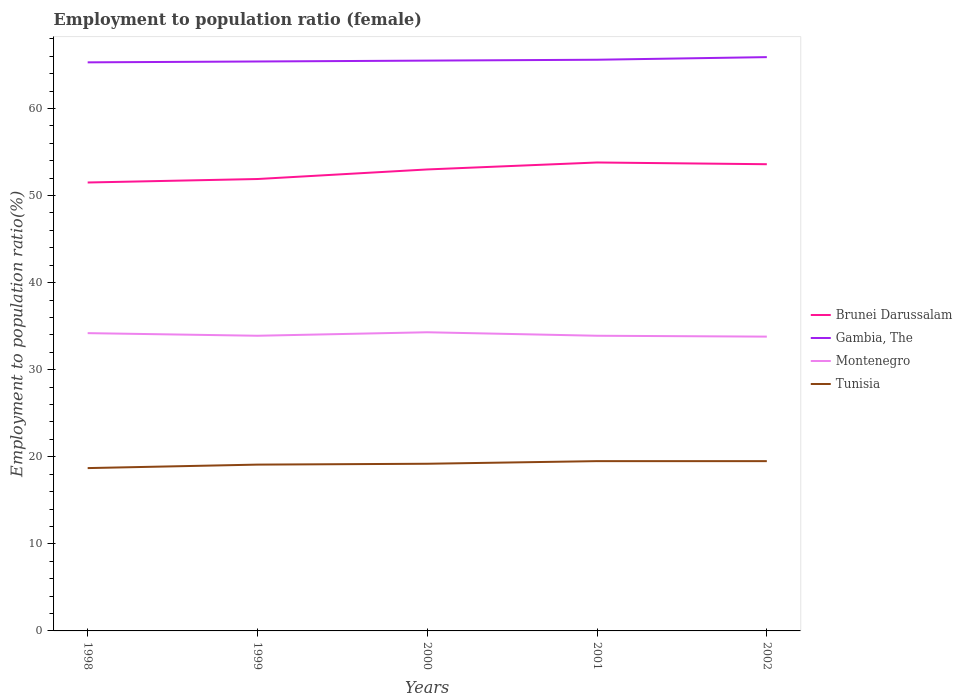Does the line corresponding to Tunisia intersect with the line corresponding to Brunei Darussalam?
Ensure brevity in your answer.  No. Is the number of lines equal to the number of legend labels?
Your response must be concise. Yes. Across all years, what is the maximum employment to population ratio in Brunei Darussalam?
Give a very brief answer. 51.5. In which year was the employment to population ratio in Brunei Darussalam maximum?
Make the answer very short. 1998. What is the total employment to population ratio in Gambia, The in the graph?
Provide a succinct answer. -0.1. What is the difference between the highest and the lowest employment to population ratio in Montenegro?
Ensure brevity in your answer.  2. Is the employment to population ratio in Tunisia strictly greater than the employment to population ratio in Brunei Darussalam over the years?
Your answer should be very brief. Yes. How many lines are there?
Offer a very short reply. 4. How many years are there in the graph?
Make the answer very short. 5. What is the difference between two consecutive major ticks on the Y-axis?
Your answer should be very brief. 10. Does the graph contain any zero values?
Your answer should be compact. No. Does the graph contain grids?
Your response must be concise. No. What is the title of the graph?
Your response must be concise. Employment to population ratio (female). Does "St. Kitts and Nevis" appear as one of the legend labels in the graph?
Your response must be concise. No. What is the label or title of the X-axis?
Provide a succinct answer. Years. What is the Employment to population ratio(%) of Brunei Darussalam in 1998?
Offer a very short reply. 51.5. What is the Employment to population ratio(%) of Gambia, The in 1998?
Your response must be concise. 65.3. What is the Employment to population ratio(%) in Montenegro in 1998?
Your response must be concise. 34.2. What is the Employment to population ratio(%) of Tunisia in 1998?
Your answer should be very brief. 18.7. What is the Employment to population ratio(%) in Brunei Darussalam in 1999?
Offer a very short reply. 51.9. What is the Employment to population ratio(%) of Gambia, The in 1999?
Your answer should be very brief. 65.4. What is the Employment to population ratio(%) of Montenegro in 1999?
Your response must be concise. 33.9. What is the Employment to population ratio(%) of Tunisia in 1999?
Make the answer very short. 19.1. What is the Employment to population ratio(%) of Brunei Darussalam in 2000?
Your answer should be compact. 53. What is the Employment to population ratio(%) of Gambia, The in 2000?
Your answer should be compact. 65.5. What is the Employment to population ratio(%) in Montenegro in 2000?
Give a very brief answer. 34.3. What is the Employment to population ratio(%) of Tunisia in 2000?
Give a very brief answer. 19.2. What is the Employment to population ratio(%) of Brunei Darussalam in 2001?
Provide a succinct answer. 53.8. What is the Employment to population ratio(%) in Gambia, The in 2001?
Ensure brevity in your answer.  65.6. What is the Employment to population ratio(%) in Montenegro in 2001?
Make the answer very short. 33.9. What is the Employment to population ratio(%) in Tunisia in 2001?
Make the answer very short. 19.5. What is the Employment to population ratio(%) of Brunei Darussalam in 2002?
Offer a very short reply. 53.6. What is the Employment to population ratio(%) in Gambia, The in 2002?
Make the answer very short. 65.9. What is the Employment to population ratio(%) in Montenegro in 2002?
Your answer should be very brief. 33.8. What is the Employment to population ratio(%) of Tunisia in 2002?
Give a very brief answer. 19.5. Across all years, what is the maximum Employment to population ratio(%) of Brunei Darussalam?
Your answer should be very brief. 53.8. Across all years, what is the maximum Employment to population ratio(%) in Gambia, The?
Ensure brevity in your answer.  65.9. Across all years, what is the maximum Employment to population ratio(%) of Montenegro?
Provide a short and direct response. 34.3. Across all years, what is the minimum Employment to population ratio(%) in Brunei Darussalam?
Make the answer very short. 51.5. Across all years, what is the minimum Employment to population ratio(%) in Gambia, The?
Give a very brief answer. 65.3. Across all years, what is the minimum Employment to population ratio(%) in Montenegro?
Your response must be concise. 33.8. Across all years, what is the minimum Employment to population ratio(%) of Tunisia?
Ensure brevity in your answer.  18.7. What is the total Employment to population ratio(%) of Brunei Darussalam in the graph?
Your response must be concise. 263.8. What is the total Employment to population ratio(%) of Gambia, The in the graph?
Offer a very short reply. 327.7. What is the total Employment to population ratio(%) of Montenegro in the graph?
Give a very brief answer. 170.1. What is the total Employment to population ratio(%) of Tunisia in the graph?
Offer a terse response. 96. What is the difference between the Employment to population ratio(%) in Brunei Darussalam in 1998 and that in 1999?
Provide a short and direct response. -0.4. What is the difference between the Employment to population ratio(%) of Brunei Darussalam in 1998 and that in 2000?
Your answer should be compact. -1.5. What is the difference between the Employment to population ratio(%) of Gambia, The in 1998 and that in 2000?
Offer a terse response. -0.2. What is the difference between the Employment to population ratio(%) of Montenegro in 1998 and that in 2000?
Provide a short and direct response. -0.1. What is the difference between the Employment to population ratio(%) of Tunisia in 1998 and that in 2000?
Ensure brevity in your answer.  -0.5. What is the difference between the Employment to population ratio(%) of Gambia, The in 1998 and that in 2001?
Offer a terse response. -0.3. What is the difference between the Employment to population ratio(%) in Tunisia in 1998 and that in 2001?
Make the answer very short. -0.8. What is the difference between the Employment to population ratio(%) in Brunei Darussalam in 1998 and that in 2002?
Make the answer very short. -2.1. What is the difference between the Employment to population ratio(%) in Gambia, The in 1998 and that in 2002?
Your answer should be very brief. -0.6. What is the difference between the Employment to population ratio(%) of Montenegro in 1998 and that in 2002?
Provide a short and direct response. 0.4. What is the difference between the Employment to population ratio(%) of Tunisia in 1998 and that in 2002?
Your response must be concise. -0.8. What is the difference between the Employment to population ratio(%) in Brunei Darussalam in 1999 and that in 2000?
Make the answer very short. -1.1. What is the difference between the Employment to population ratio(%) in Brunei Darussalam in 1999 and that in 2001?
Provide a short and direct response. -1.9. What is the difference between the Employment to population ratio(%) in Montenegro in 1999 and that in 2001?
Your response must be concise. 0. What is the difference between the Employment to population ratio(%) in Brunei Darussalam in 2000 and that in 2001?
Provide a short and direct response. -0.8. What is the difference between the Employment to population ratio(%) in Montenegro in 2000 and that in 2001?
Provide a short and direct response. 0.4. What is the difference between the Employment to population ratio(%) of Montenegro in 2000 and that in 2002?
Offer a terse response. 0.5. What is the difference between the Employment to population ratio(%) in Brunei Darussalam in 2001 and that in 2002?
Offer a very short reply. 0.2. What is the difference between the Employment to population ratio(%) in Gambia, The in 2001 and that in 2002?
Offer a terse response. -0.3. What is the difference between the Employment to population ratio(%) in Montenegro in 2001 and that in 2002?
Keep it short and to the point. 0.1. What is the difference between the Employment to population ratio(%) in Tunisia in 2001 and that in 2002?
Provide a short and direct response. 0. What is the difference between the Employment to population ratio(%) in Brunei Darussalam in 1998 and the Employment to population ratio(%) in Gambia, The in 1999?
Ensure brevity in your answer.  -13.9. What is the difference between the Employment to population ratio(%) of Brunei Darussalam in 1998 and the Employment to population ratio(%) of Montenegro in 1999?
Give a very brief answer. 17.6. What is the difference between the Employment to population ratio(%) in Brunei Darussalam in 1998 and the Employment to population ratio(%) in Tunisia in 1999?
Offer a terse response. 32.4. What is the difference between the Employment to population ratio(%) of Gambia, The in 1998 and the Employment to population ratio(%) of Montenegro in 1999?
Provide a short and direct response. 31.4. What is the difference between the Employment to population ratio(%) in Gambia, The in 1998 and the Employment to population ratio(%) in Tunisia in 1999?
Give a very brief answer. 46.2. What is the difference between the Employment to population ratio(%) in Montenegro in 1998 and the Employment to population ratio(%) in Tunisia in 1999?
Give a very brief answer. 15.1. What is the difference between the Employment to population ratio(%) in Brunei Darussalam in 1998 and the Employment to population ratio(%) in Gambia, The in 2000?
Your response must be concise. -14. What is the difference between the Employment to population ratio(%) of Brunei Darussalam in 1998 and the Employment to population ratio(%) of Montenegro in 2000?
Offer a terse response. 17.2. What is the difference between the Employment to population ratio(%) of Brunei Darussalam in 1998 and the Employment to population ratio(%) of Tunisia in 2000?
Your response must be concise. 32.3. What is the difference between the Employment to population ratio(%) of Gambia, The in 1998 and the Employment to population ratio(%) of Tunisia in 2000?
Keep it short and to the point. 46.1. What is the difference between the Employment to population ratio(%) of Montenegro in 1998 and the Employment to population ratio(%) of Tunisia in 2000?
Provide a succinct answer. 15. What is the difference between the Employment to population ratio(%) in Brunei Darussalam in 1998 and the Employment to population ratio(%) in Gambia, The in 2001?
Make the answer very short. -14.1. What is the difference between the Employment to population ratio(%) in Brunei Darussalam in 1998 and the Employment to population ratio(%) in Montenegro in 2001?
Your response must be concise. 17.6. What is the difference between the Employment to population ratio(%) of Gambia, The in 1998 and the Employment to population ratio(%) of Montenegro in 2001?
Your response must be concise. 31.4. What is the difference between the Employment to population ratio(%) in Gambia, The in 1998 and the Employment to population ratio(%) in Tunisia in 2001?
Provide a succinct answer. 45.8. What is the difference between the Employment to population ratio(%) in Montenegro in 1998 and the Employment to population ratio(%) in Tunisia in 2001?
Give a very brief answer. 14.7. What is the difference between the Employment to population ratio(%) in Brunei Darussalam in 1998 and the Employment to population ratio(%) in Gambia, The in 2002?
Provide a short and direct response. -14.4. What is the difference between the Employment to population ratio(%) in Brunei Darussalam in 1998 and the Employment to population ratio(%) in Montenegro in 2002?
Make the answer very short. 17.7. What is the difference between the Employment to population ratio(%) in Gambia, The in 1998 and the Employment to population ratio(%) in Montenegro in 2002?
Ensure brevity in your answer.  31.5. What is the difference between the Employment to population ratio(%) of Gambia, The in 1998 and the Employment to population ratio(%) of Tunisia in 2002?
Your answer should be very brief. 45.8. What is the difference between the Employment to population ratio(%) of Brunei Darussalam in 1999 and the Employment to population ratio(%) of Tunisia in 2000?
Your response must be concise. 32.7. What is the difference between the Employment to population ratio(%) in Gambia, The in 1999 and the Employment to population ratio(%) in Montenegro in 2000?
Provide a succinct answer. 31.1. What is the difference between the Employment to population ratio(%) in Gambia, The in 1999 and the Employment to population ratio(%) in Tunisia in 2000?
Make the answer very short. 46.2. What is the difference between the Employment to population ratio(%) in Brunei Darussalam in 1999 and the Employment to population ratio(%) in Gambia, The in 2001?
Ensure brevity in your answer.  -13.7. What is the difference between the Employment to population ratio(%) in Brunei Darussalam in 1999 and the Employment to population ratio(%) in Tunisia in 2001?
Your answer should be compact. 32.4. What is the difference between the Employment to population ratio(%) of Gambia, The in 1999 and the Employment to population ratio(%) of Montenegro in 2001?
Keep it short and to the point. 31.5. What is the difference between the Employment to population ratio(%) in Gambia, The in 1999 and the Employment to population ratio(%) in Tunisia in 2001?
Your answer should be very brief. 45.9. What is the difference between the Employment to population ratio(%) of Montenegro in 1999 and the Employment to population ratio(%) of Tunisia in 2001?
Ensure brevity in your answer.  14.4. What is the difference between the Employment to population ratio(%) in Brunei Darussalam in 1999 and the Employment to population ratio(%) in Montenegro in 2002?
Ensure brevity in your answer.  18.1. What is the difference between the Employment to population ratio(%) in Brunei Darussalam in 1999 and the Employment to population ratio(%) in Tunisia in 2002?
Offer a very short reply. 32.4. What is the difference between the Employment to population ratio(%) of Gambia, The in 1999 and the Employment to population ratio(%) of Montenegro in 2002?
Your answer should be compact. 31.6. What is the difference between the Employment to population ratio(%) of Gambia, The in 1999 and the Employment to population ratio(%) of Tunisia in 2002?
Provide a short and direct response. 45.9. What is the difference between the Employment to population ratio(%) of Montenegro in 1999 and the Employment to population ratio(%) of Tunisia in 2002?
Keep it short and to the point. 14.4. What is the difference between the Employment to population ratio(%) of Brunei Darussalam in 2000 and the Employment to population ratio(%) of Gambia, The in 2001?
Keep it short and to the point. -12.6. What is the difference between the Employment to population ratio(%) of Brunei Darussalam in 2000 and the Employment to population ratio(%) of Montenegro in 2001?
Give a very brief answer. 19.1. What is the difference between the Employment to population ratio(%) of Brunei Darussalam in 2000 and the Employment to population ratio(%) of Tunisia in 2001?
Your answer should be compact. 33.5. What is the difference between the Employment to population ratio(%) of Gambia, The in 2000 and the Employment to population ratio(%) of Montenegro in 2001?
Your response must be concise. 31.6. What is the difference between the Employment to population ratio(%) of Brunei Darussalam in 2000 and the Employment to population ratio(%) of Montenegro in 2002?
Your answer should be compact. 19.2. What is the difference between the Employment to population ratio(%) in Brunei Darussalam in 2000 and the Employment to population ratio(%) in Tunisia in 2002?
Give a very brief answer. 33.5. What is the difference between the Employment to population ratio(%) in Gambia, The in 2000 and the Employment to population ratio(%) in Montenegro in 2002?
Keep it short and to the point. 31.7. What is the difference between the Employment to population ratio(%) of Gambia, The in 2000 and the Employment to population ratio(%) of Tunisia in 2002?
Provide a succinct answer. 46. What is the difference between the Employment to population ratio(%) of Montenegro in 2000 and the Employment to population ratio(%) of Tunisia in 2002?
Your response must be concise. 14.8. What is the difference between the Employment to population ratio(%) in Brunei Darussalam in 2001 and the Employment to population ratio(%) in Tunisia in 2002?
Keep it short and to the point. 34.3. What is the difference between the Employment to population ratio(%) in Gambia, The in 2001 and the Employment to population ratio(%) in Montenegro in 2002?
Your answer should be compact. 31.8. What is the difference between the Employment to population ratio(%) of Gambia, The in 2001 and the Employment to population ratio(%) of Tunisia in 2002?
Provide a succinct answer. 46.1. What is the difference between the Employment to population ratio(%) in Montenegro in 2001 and the Employment to population ratio(%) in Tunisia in 2002?
Your response must be concise. 14.4. What is the average Employment to population ratio(%) of Brunei Darussalam per year?
Make the answer very short. 52.76. What is the average Employment to population ratio(%) in Gambia, The per year?
Offer a terse response. 65.54. What is the average Employment to population ratio(%) in Montenegro per year?
Ensure brevity in your answer.  34.02. In the year 1998, what is the difference between the Employment to population ratio(%) of Brunei Darussalam and Employment to population ratio(%) of Gambia, The?
Your response must be concise. -13.8. In the year 1998, what is the difference between the Employment to population ratio(%) of Brunei Darussalam and Employment to population ratio(%) of Tunisia?
Your answer should be very brief. 32.8. In the year 1998, what is the difference between the Employment to population ratio(%) in Gambia, The and Employment to population ratio(%) in Montenegro?
Your answer should be compact. 31.1. In the year 1998, what is the difference between the Employment to population ratio(%) of Gambia, The and Employment to population ratio(%) of Tunisia?
Offer a very short reply. 46.6. In the year 1999, what is the difference between the Employment to population ratio(%) in Brunei Darussalam and Employment to population ratio(%) in Tunisia?
Provide a short and direct response. 32.8. In the year 1999, what is the difference between the Employment to population ratio(%) in Gambia, The and Employment to population ratio(%) in Montenegro?
Ensure brevity in your answer.  31.5. In the year 1999, what is the difference between the Employment to population ratio(%) of Gambia, The and Employment to population ratio(%) of Tunisia?
Make the answer very short. 46.3. In the year 2000, what is the difference between the Employment to population ratio(%) of Brunei Darussalam and Employment to population ratio(%) of Tunisia?
Make the answer very short. 33.8. In the year 2000, what is the difference between the Employment to population ratio(%) in Gambia, The and Employment to population ratio(%) in Montenegro?
Provide a succinct answer. 31.2. In the year 2000, what is the difference between the Employment to population ratio(%) in Gambia, The and Employment to population ratio(%) in Tunisia?
Your response must be concise. 46.3. In the year 2000, what is the difference between the Employment to population ratio(%) of Montenegro and Employment to population ratio(%) of Tunisia?
Offer a terse response. 15.1. In the year 2001, what is the difference between the Employment to population ratio(%) in Brunei Darussalam and Employment to population ratio(%) in Montenegro?
Your answer should be compact. 19.9. In the year 2001, what is the difference between the Employment to population ratio(%) of Brunei Darussalam and Employment to population ratio(%) of Tunisia?
Make the answer very short. 34.3. In the year 2001, what is the difference between the Employment to population ratio(%) in Gambia, The and Employment to population ratio(%) in Montenegro?
Provide a short and direct response. 31.7. In the year 2001, what is the difference between the Employment to population ratio(%) in Gambia, The and Employment to population ratio(%) in Tunisia?
Offer a terse response. 46.1. In the year 2001, what is the difference between the Employment to population ratio(%) in Montenegro and Employment to population ratio(%) in Tunisia?
Your response must be concise. 14.4. In the year 2002, what is the difference between the Employment to population ratio(%) in Brunei Darussalam and Employment to population ratio(%) in Gambia, The?
Keep it short and to the point. -12.3. In the year 2002, what is the difference between the Employment to population ratio(%) in Brunei Darussalam and Employment to population ratio(%) in Montenegro?
Give a very brief answer. 19.8. In the year 2002, what is the difference between the Employment to population ratio(%) in Brunei Darussalam and Employment to population ratio(%) in Tunisia?
Your answer should be very brief. 34.1. In the year 2002, what is the difference between the Employment to population ratio(%) of Gambia, The and Employment to population ratio(%) of Montenegro?
Your response must be concise. 32.1. In the year 2002, what is the difference between the Employment to population ratio(%) of Gambia, The and Employment to population ratio(%) of Tunisia?
Give a very brief answer. 46.4. In the year 2002, what is the difference between the Employment to population ratio(%) in Montenegro and Employment to population ratio(%) in Tunisia?
Keep it short and to the point. 14.3. What is the ratio of the Employment to population ratio(%) of Brunei Darussalam in 1998 to that in 1999?
Provide a short and direct response. 0.99. What is the ratio of the Employment to population ratio(%) of Gambia, The in 1998 to that in 1999?
Give a very brief answer. 1. What is the ratio of the Employment to population ratio(%) in Montenegro in 1998 to that in 1999?
Your answer should be compact. 1.01. What is the ratio of the Employment to population ratio(%) in Tunisia in 1998 to that in 1999?
Provide a succinct answer. 0.98. What is the ratio of the Employment to population ratio(%) in Brunei Darussalam in 1998 to that in 2000?
Keep it short and to the point. 0.97. What is the ratio of the Employment to population ratio(%) of Gambia, The in 1998 to that in 2000?
Make the answer very short. 1. What is the ratio of the Employment to population ratio(%) in Montenegro in 1998 to that in 2000?
Your answer should be very brief. 1. What is the ratio of the Employment to population ratio(%) in Brunei Darussalam in 1998 to that in 2001?
Ensure brevity in your answer.  0.96. What is the ratio of the Employment to population ratio(%) in Montenegro in 1998 to that in 2001?
Make the answer very short. 1.01. What is the ratio of the Employment to population ratio(%) of Brunei Darussalam in 1998 to that in 2002?
Give a very brief answer. 0.96. What is the ratio of the Employment to population ratio(%) of Gambia, The in 1998 to that in 2002?
Your answer should be very brief. 0.99. What is the ratio of the Employment to population ratio(%) of Montenegro in 1998 to that in 2002?
Offer a very short reply. 1.01. What is the ratio of the Employment to population ratio(%) of Brunei Darussalam in 1999 to that in 2000?
Give a very brief answer. 0.98. What is the ratio of the Employment to population ratio(%) of Montenegro in 1999 to that in 2000?
Provide a succinct answer. 0.99. What is the ratio of the Employment to population ratio(%) in Brunei Darussalam in 1999 to that in 2001?
Ensure brevity in your answer.  0.96. What is the ratio of the Employment to population ratio(%) of Gambia, The in 1999 to that in 2001?
Your answer should be very brief. 1. What is the ratio of the Employment to population ratio(%) in Tunisia in 1999 to that in 2001?
Give a very brief answer. 0.98. What is the ratio of the Employment to population ratio(%) in Brunei Darussalam in 1999 to that in 2002?
Offer a very short reply. 0.97. What is the ratio of the Employment to population ratio(%) of Montenegro in 1999 to that in 2002?
Provide a short and direct response. 1. What is the ratio of the Employment to population ratio(%) in Tunisia in 1999 to that in 2002?
Give a very brief answer. 0.98. What is the ratio of the Employment to population ratio(%) of Brunei Darussalam in 2000 to that in 2001?
Ensure brevity in your answer.  0.99. What is the ratio of the Employment to population ratio(%) of Gambia, The in 2000 to that in 2001?
Give a very brief answer. 1. What is the ratio of the Employment to population ratio(%) in Montenegro in 2000 to that in 2001?
Ensure brevity in your answer.  1.01. What is the ratio of the Employment to population ratio(%) of Tunisia in 2000 to that in 2001?
Your response must be concise. 0.98. What is the ratio of the Employment to population ratio(%) in Montenegro in 2000 to that in 2002?
Provide a succinct answer. 1.01. What is the ratio of the Employment to population ratio(%) in Tunisia in 2000 to that in 2002?
Offer a very short reply. 0.98. What is the ratio of the Employment to population ratio(%) in Gambia, The in 2001 to that in 2002?
Provide a short and direct response. 1. What is the ratio of the Employment to population ratio(%) in Montenegro in 2001 to that in 2002?
Ensure brevity in your answer.  1. What is the difference between the highest and the second highest Employment to population ratio(%) of Brunei Darussalam?
Keep it short and to the point. 0.2. What is the difference between the highest and the second highest Employment to population ratio(%) in Gambia, The?
Make the answer very short. 0.3. What is the difference between the highest and the second highest Employment to population ratio(%) of Tunisia?
Your answer should be compact. 0. What is the difference between the highest and the lowest Employment to population ratio(%) in Montenegro?
Keep it short and to the point. 0.5. 